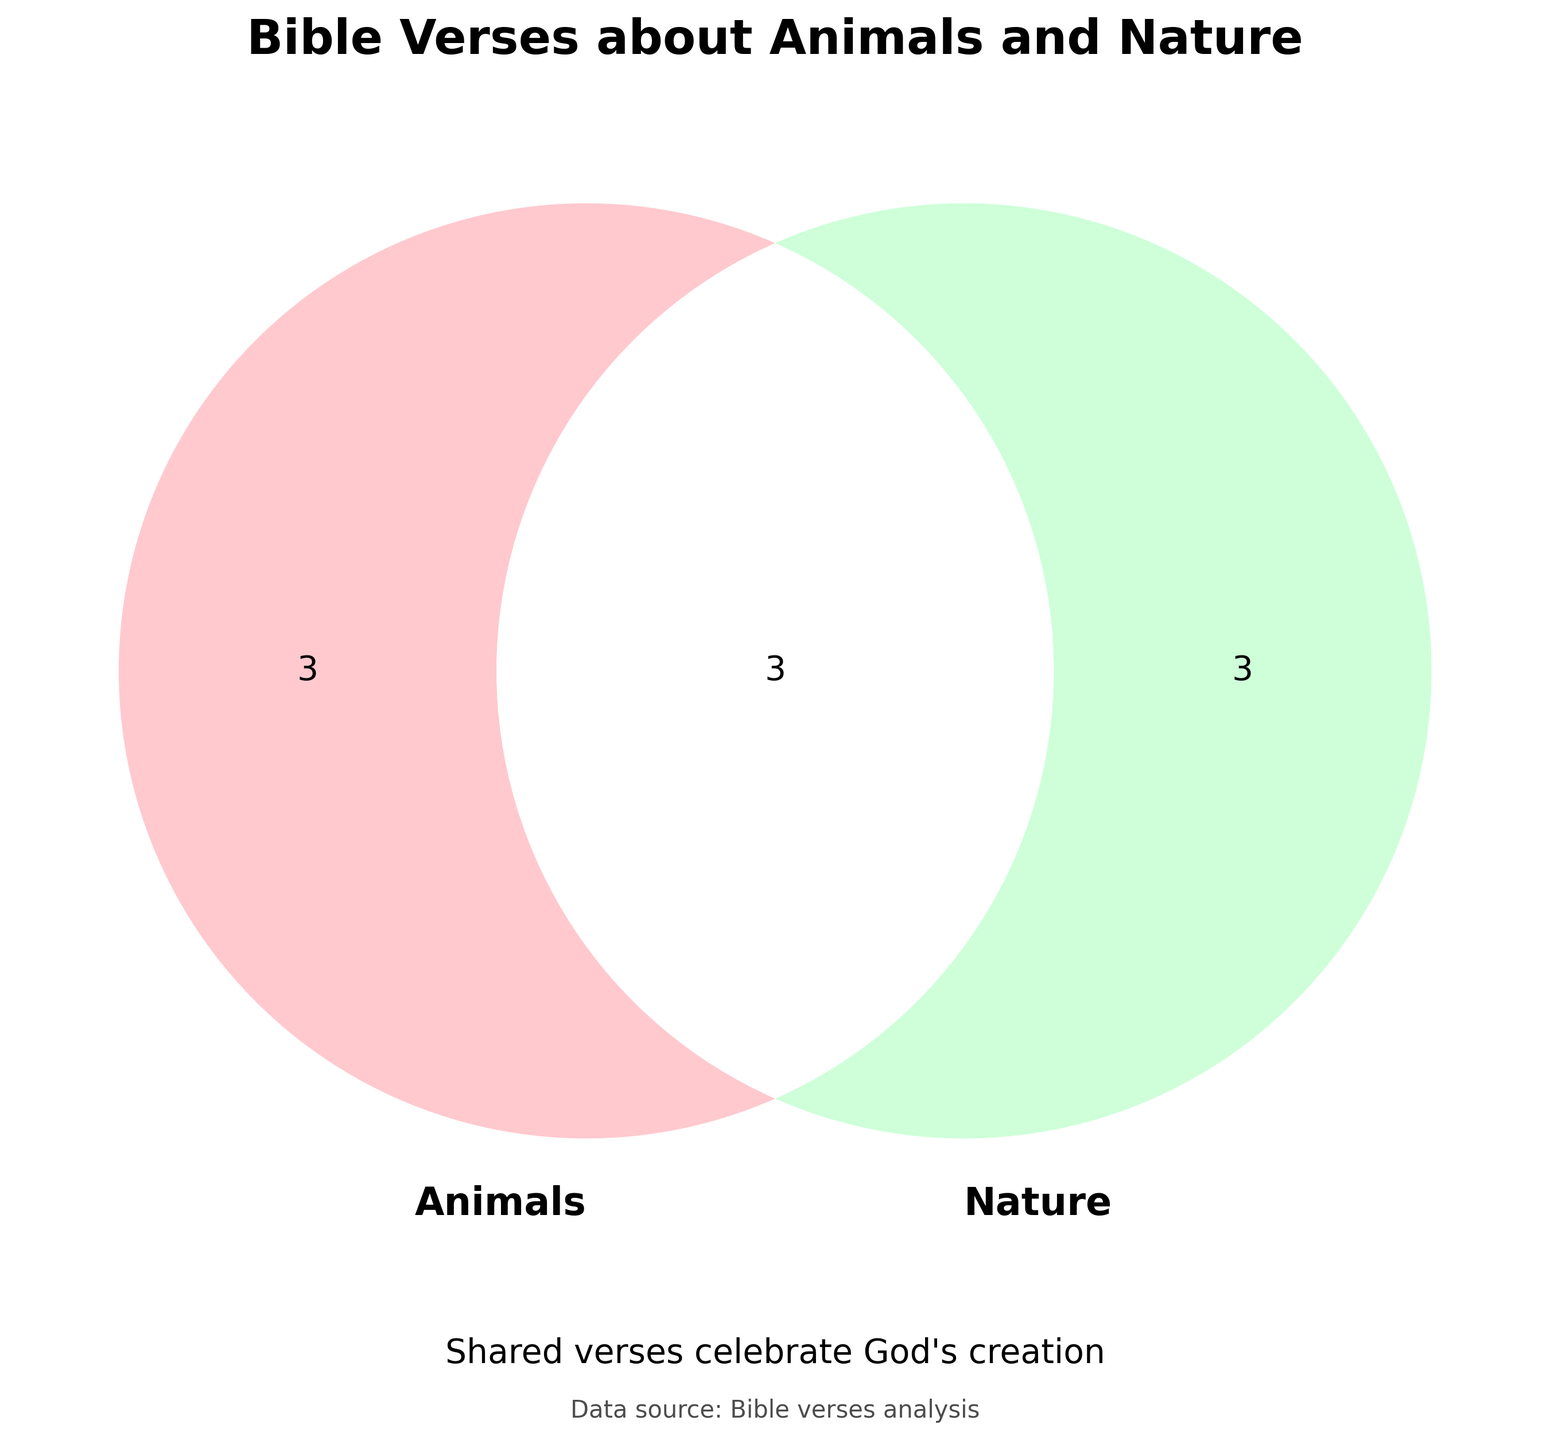What is the title of the figure? The title is displayed prominently at the top of the figure. It provides a summary of the content visually displayed in the Venn diagram.
Answer: Bible Verses about Animals and Nature How many verses are counted for both animals and nature? The number of shared verses (Both category) is shown in the overlapping section of the Venn diagram where the two circles intersect.
Answer: 3 Which category has more verses, Animals or Nature? By comparing the sizes of the non-overlapping sections of the circles, we can determine which category has more verses. The number of verses for Animals (4) plus Both (3) is 7, while for Nature (2) plus Both (3) is 5. Therefore, Animals has more.
Answer: Animals What is the color of the circle representing Animals? The color of the circle representing Animals is indicated by its shading in the Venn diagram.
Answer: Pink How many verses are there in total for both categories combined? To find the total number of verses, add up all the unique and shared verses shown in the Venn diagram: (Animals only) 4 + (Nature only) 2 + (Both) 3.
Answer: 9 Which specific Bible verses are shared between Animals and Nature? The verses in the overlapping section labeled as "Both" represent the shared verses.
Answer: Genesis 1:20-25, Job 12:7-10, Psalm 148:7-10 